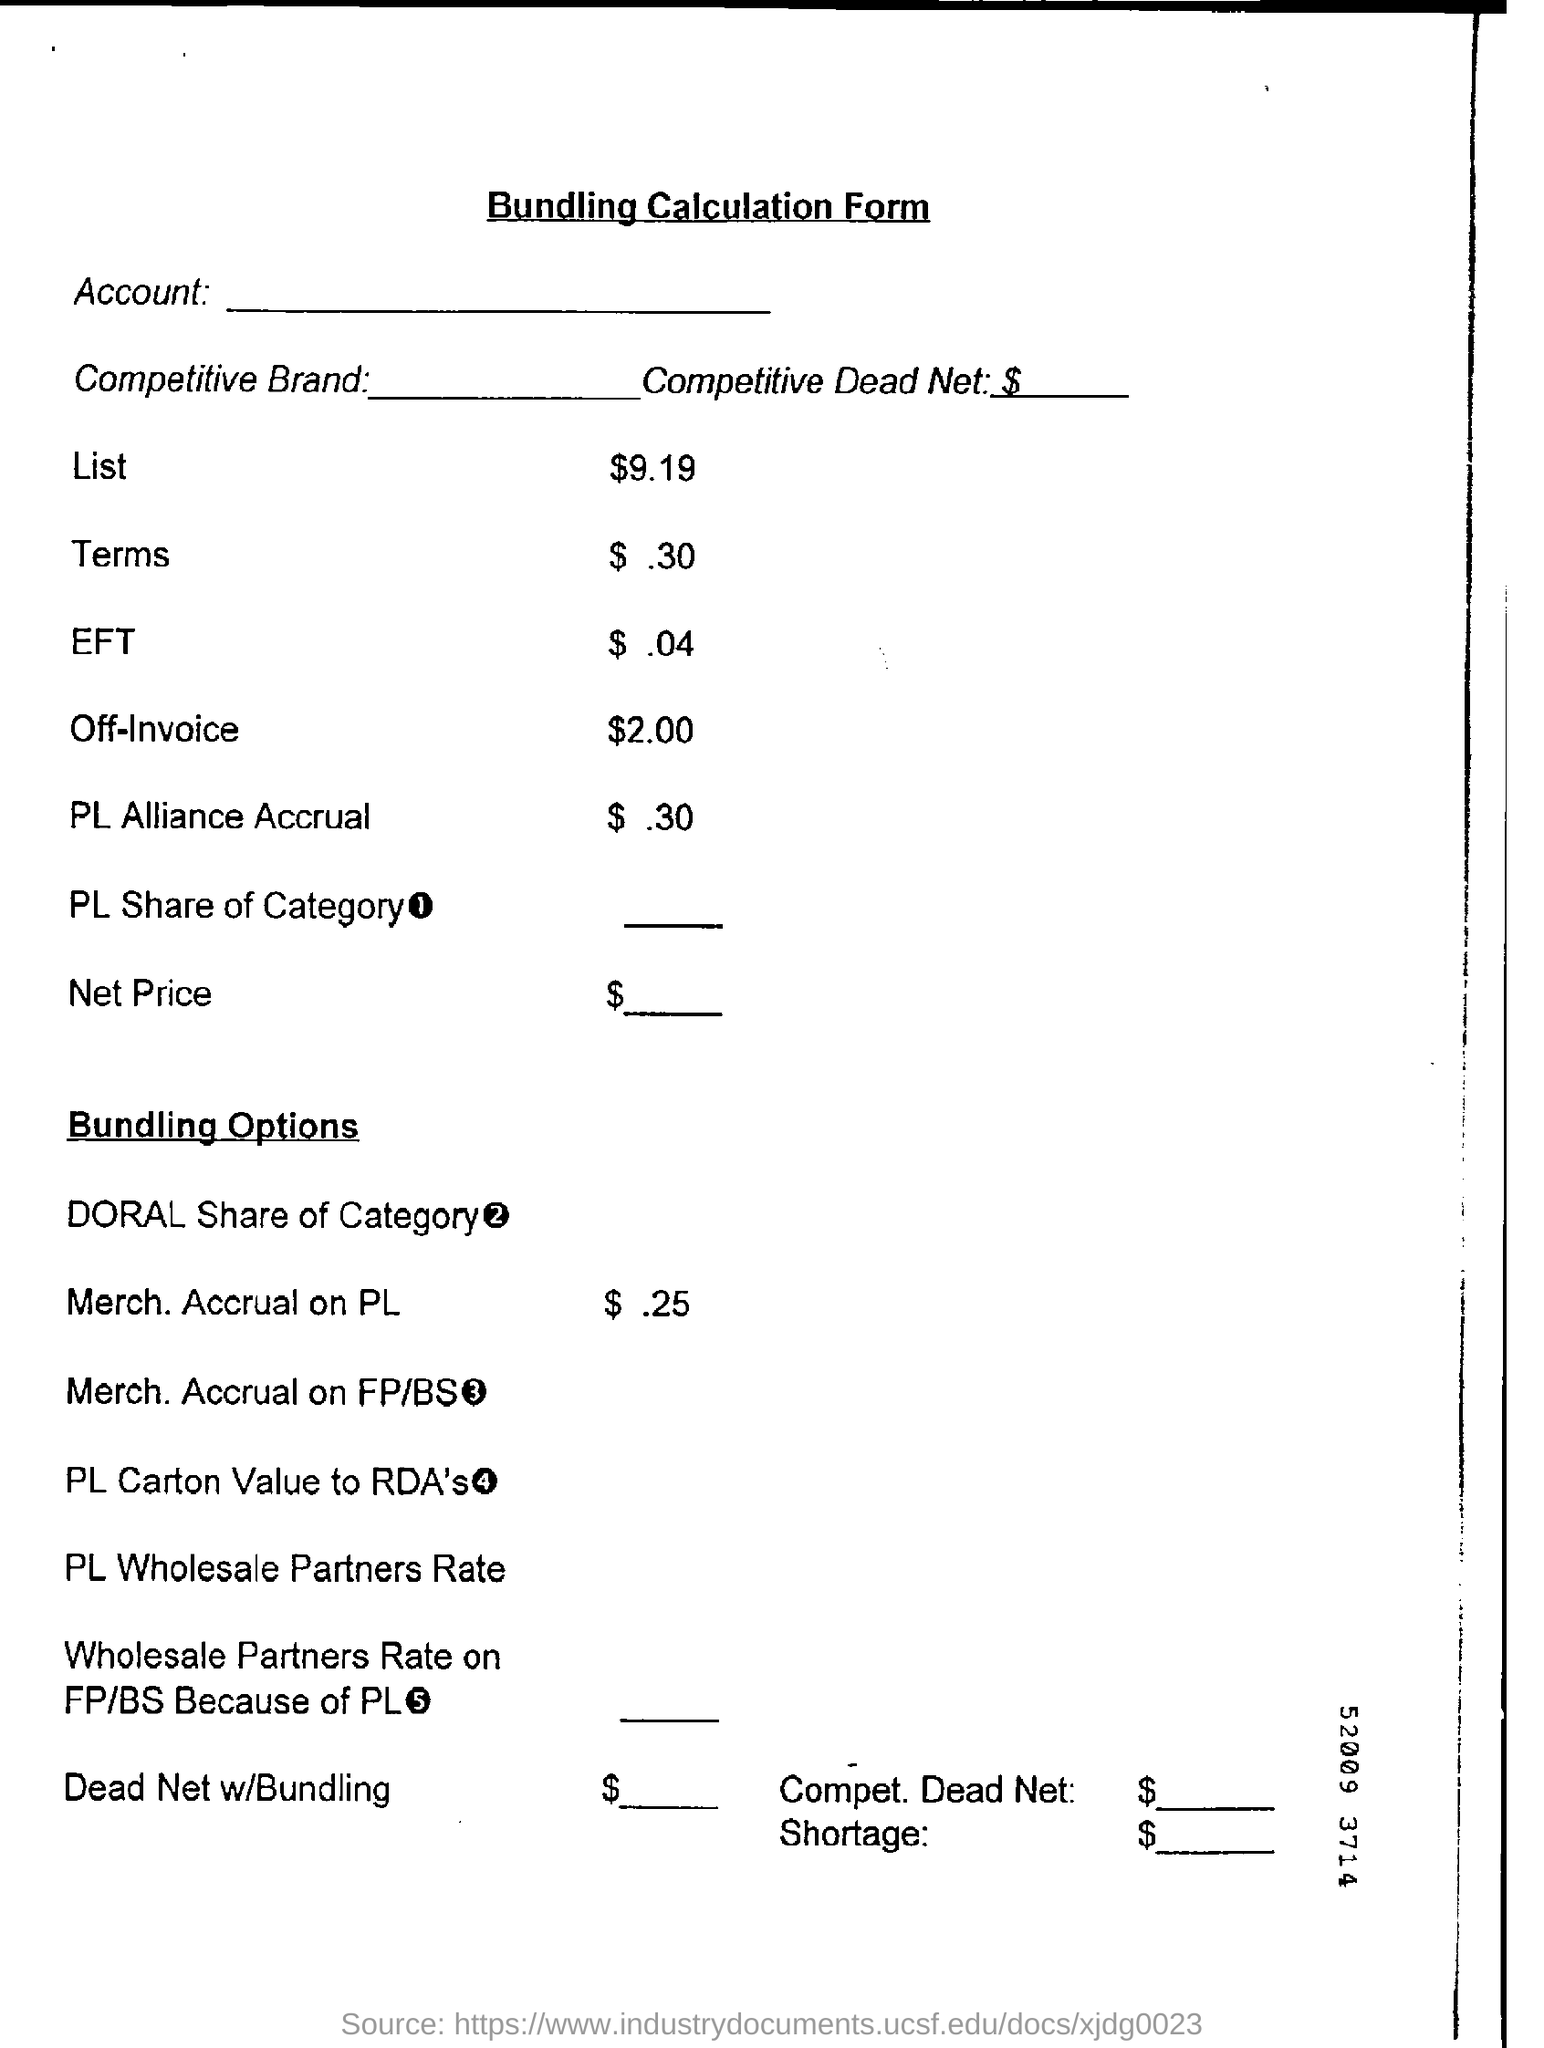What is the title of the document?
Provide a short and direct response. Bundling Calculation Form. 